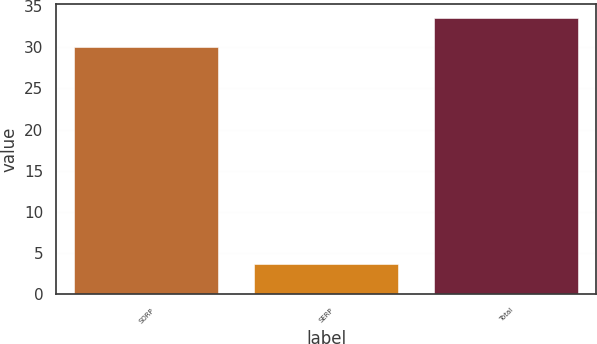<chart> <loc_0><loc_0><loc_500><loc_500><bar_chart><fcel>SORP<fcel>SERP<fcel>Total<nl><fcel>30<fcel>3.6<fcel>33.6<nl></chart> 